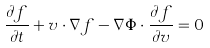<formula> <loc_0><loc_0><loc_500><loc_500>\frac { \partial f } { \partial t } + v \cdot \nabla f - \nabla \Phi \cdot \frac { \partial f } { \partial v } = 0</formula> 